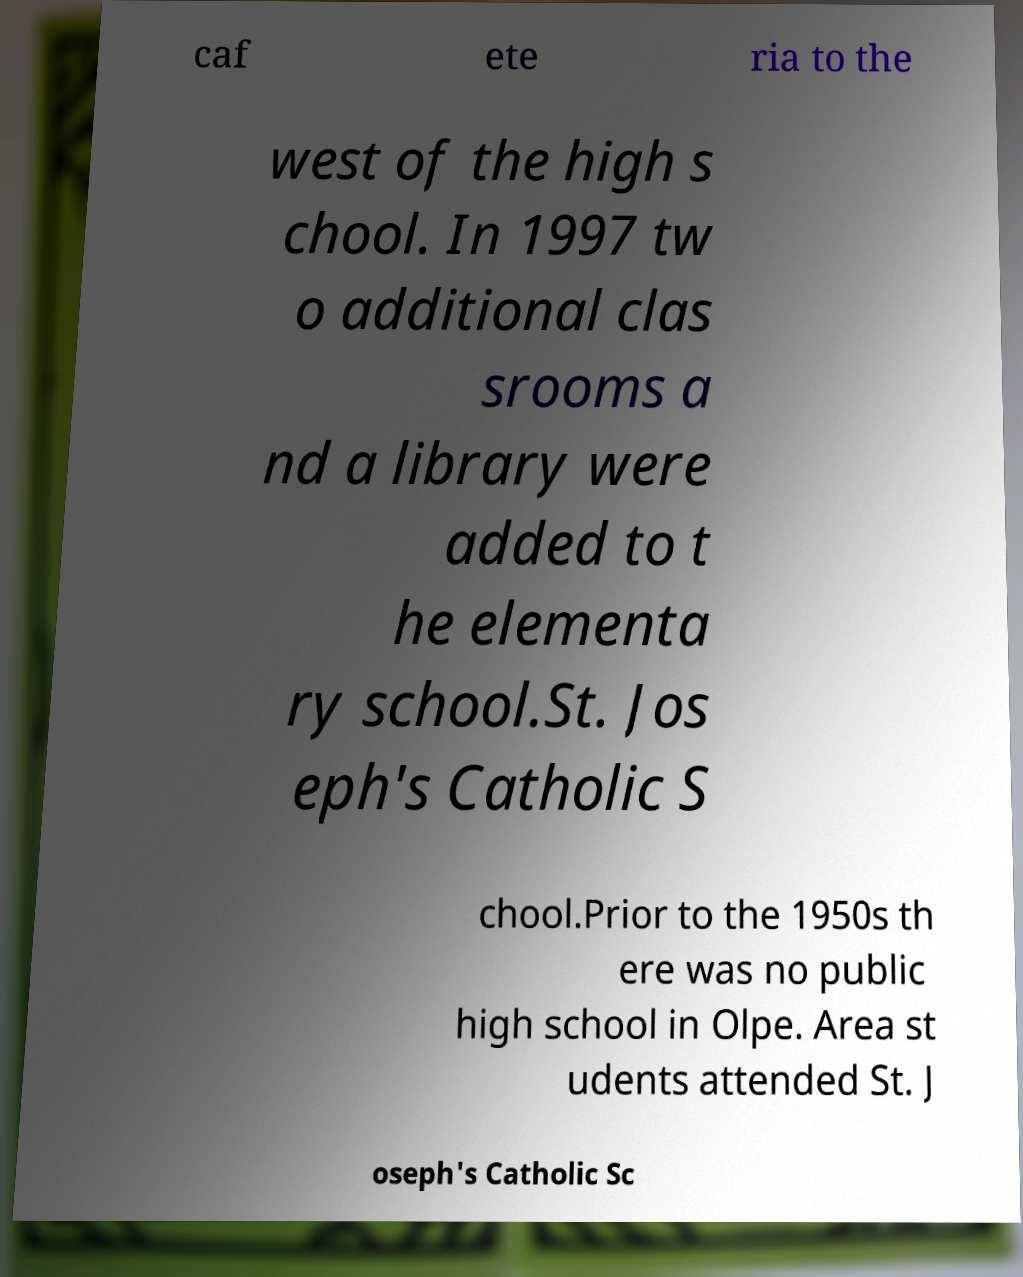There's text embedded in this image that I need extracted. Can you transcribe it verbatim? caf ete ria to the west of the high s chool. In 1997 tw o additional clas srooms a nd a library were added to t he elementa ry school.St. Jos eph's Catholic S chool.Prior to the 1950s th ere was no public high school in Olpe. Area st udents attended St. J oseph's Catholic Sc 